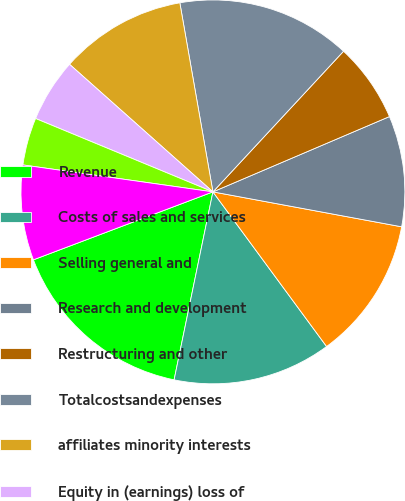<chart> <loc_0><loc_0><loc_500><loc_500><pie_chart><fcel>Revenue<fcel>Costs of sales and services<fcel>Selling general and<fcel>Research and development<fcel>Restructuring and other<fcel>Totalcostsandexpenses<fcel>affiliates minority interests<fcel>Equity in (earnings) loss of<fcel>Minority interests<fcel>Netincome(loss)<nl><fcel>16.0%<fcel>13.33%<fcel>12.0%<fcel>9.33%<fcel>6.67%<fcel>14.67%<fcel>10.67%<fcel>5.33%<fcel>4.0%<fcel>8.0%<nl></chart> 